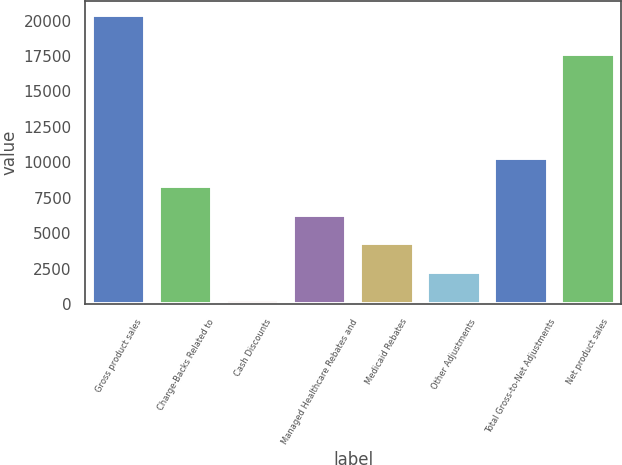Convert chart. <chart><loc_0><loc_0><loc_500><loc_500><bar_chart><fcel>Gross product sales<fcel>Charge-Backs Related to<fcel>Cash Discounts<fcel>Managed Healthcare Rebates and<fcel>Medicaid Rebates<fcel>Other Adjustments<fcel>Total Gross-to-Net Adjustments<fcel>Net product sales<nl><fcel>20385<fcel>8323.2<fcel>282<fcel>6312.9<fcel>4302.6<fcel>2292.3<fcel>10333.5<fcel>17622<nl></chart> 